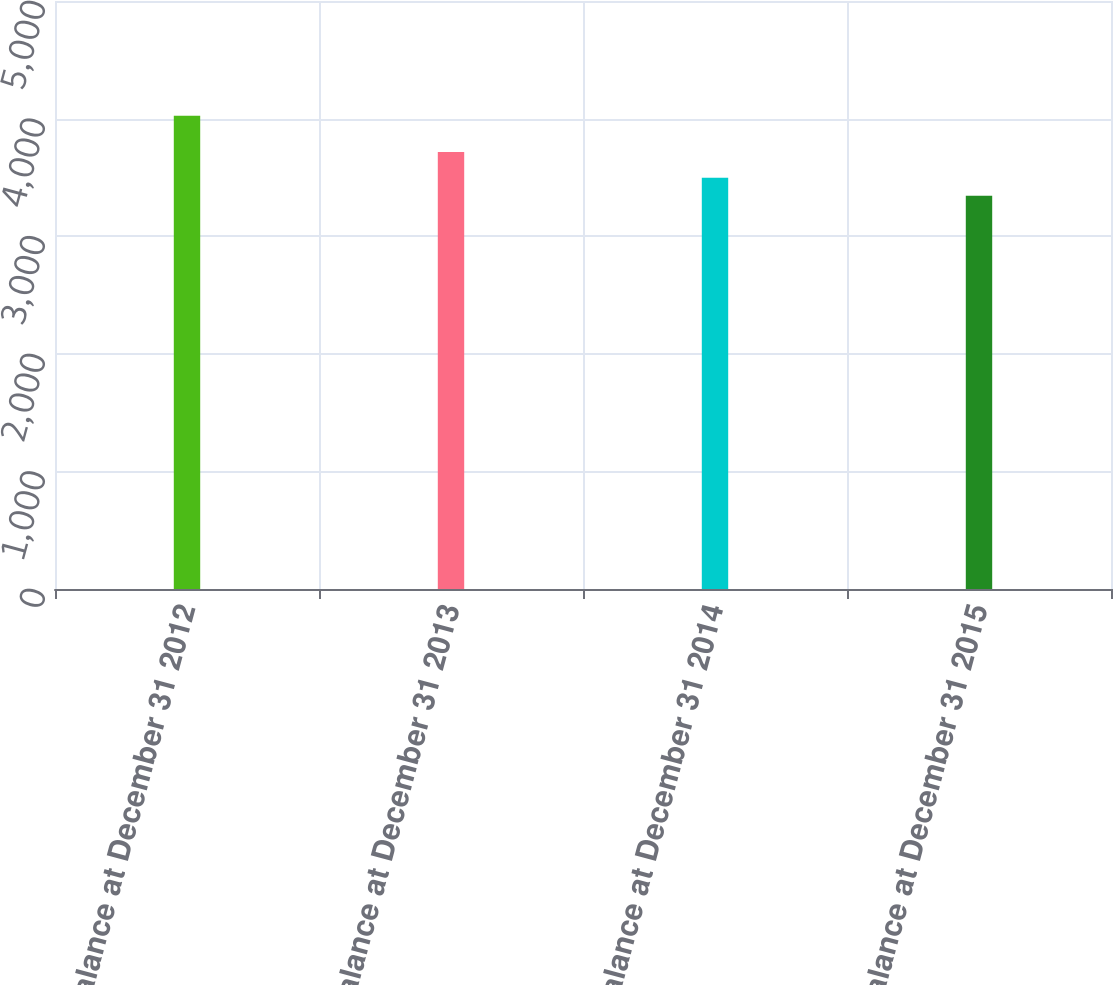Convert chart. <chart><loc_0><loc_0><loc_500><loc_500><bar_chart><fcel>Balance at December 31 2012<fcel>Balance at December 31 2013<fcel>Balance at December 31 2014<fcel>Balance at December 31 2015<nl><fcel>4024<fcel>3716<fcel>3497<fcel>3343<nl></chart> 